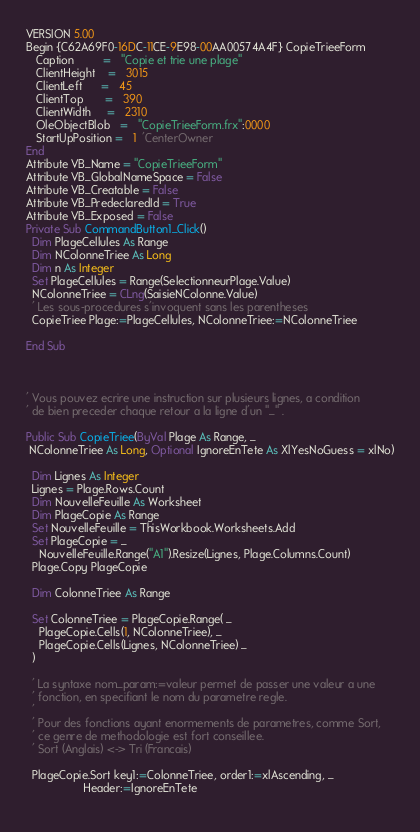<code> <loc_0><loc_0><loc_500><loc_500><_VisualBasic_>VERSION 5.00
Begin {C62A69F0-16DC-11CE-9E98-00AA00574A4F} CopieTrieeForm 
   Caption         =   "Copie et trie une plage"
   ClientHeight    =   3015
   ClientLeft      =   45
   ClientTop       =   390
   ClientWidth     =   2310
   OleObjectBlob   =   "CopieTrieeForm.frx":0000
   StartUpPosition =   1  'CenterOwner
End
Attribute VB_Name = "CopieTrieeForm"
Attribute VB_GlobalNameSpace = False
Attribute VB_Creatable = False
Attribute VB_PredeclaredId = True
Attribute VB_Exposed = False
Private Sub CommandButton1_Click()
  Dim PlageCellules As Range
  Dim NColonneTriee As Long
  Dim n As Integer
  Set PlageCellules = Range(SelectionneurPlage.Value)
  NColonneTriee = CLng(SaisieNColonne.Value)
  ' Les sous-procedures s'invoquent sans les parentheses
  CopieTriee Plage:=PlageCellules, NColonneTriee:=NColonneTriee
  
End Sub



' Vous pouvez ecrire une instruction sur plusieurs lignes, a condition
' de bien preceder chaque retour a la ligne d'un "_" .

Public Sub CopieTriee(ByVal Plage As Range, _
 NColonneTriee As Long, Optional IgnoreEnTete As XlYesNoGuess = xlNo)

  Dim Lignes As Integer
  Lignes = Plage.Rows.Count
  Dim NouvelleFeuille As Worksheet
  Dim PlageCopie As Range
  Set NouvelleFeuille = ThisWorkbook.Worksheets.Add
  Set PlageCopie = _
    NouvelleFeuille.Range("A1").Resize(Lignes, Plage.Columns.Count)
  Plage.Copy PlageCopie
  
  Dim ColonneTriee As Range

  Set ColonneTriee = PlageCopie.Range( _
    PlageCopie.Cells(1, NColonneTriee), _
    PlageCopie.Cells(Lignes, NColonneTriee) _
  )

  ' La syntaxe nom_param:=valeur permet de passer une valeur a une
  ' fonction, en specifiant le nom du parametre regle.
  '
  ' Pour des fonctions ayant enormements de parametres, comme Sort,
  ' ce genre de methodologie est fort conseillee.
  ' Sort (Anglais) <-> Tri (Francais)

  PlageCopie.Sort key1:=ColonneTriee, order1:=xlAscending, _
                  Header:=IgnoreEnTete
  </code> 